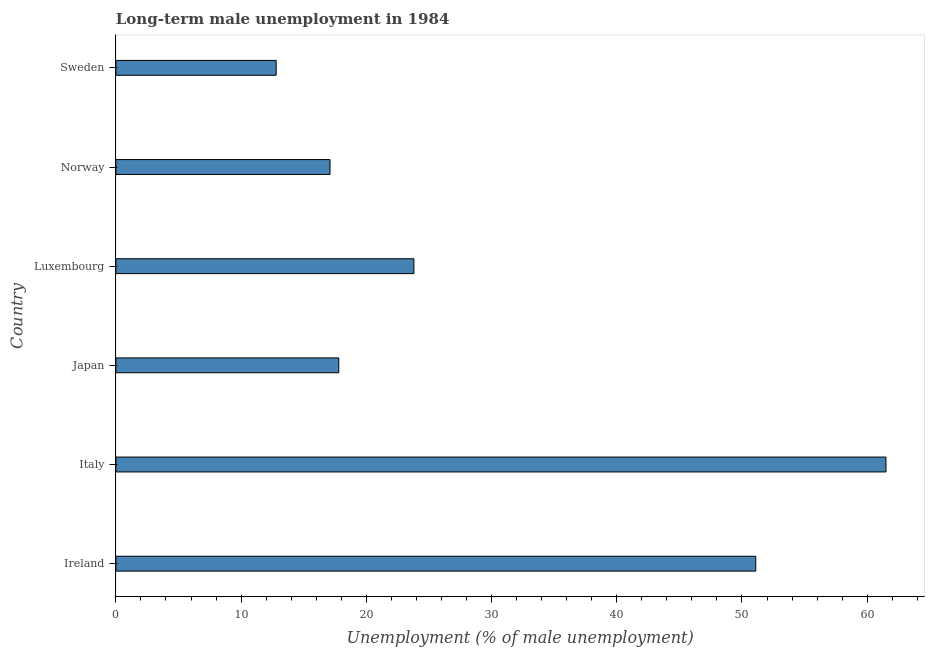Does the graph contain grids?
Offer a terse response. No. What is the title of the graph?
Provide a short and direct response. Long-term male unemployment in 1984. What is the label or title of the X-axis?
Your response must be concise. Unemployment (% of male unemployment). What is the label or title of the Y-axis?
Make the answer very short. Country. What is the long-term male unemployment in Japan?
Your response must be concise. 17.8. Across all countries, what is the maximum long-term male unemployment?
Keep it short and to the point. 61.5. Across all countries, what is the minimum long-term male unemployment?
Keep it short and to the point. 12.8. In which country was the long-term male unemployment maximum?
Keep it short and to the point. Italy. What is the sum of the long-term male unemployment?
Give a very brief answer. 184.1. What is the average long-term male unemployment per country?
Offer a terse response. 30.68. What is the median long-term male unemployment?
Offer a very short reply. 20.8. In how many countries, is the long-term male unemployment greater than 48 %?
Give a very brief answer. 2. What is the ratio of the long-term male unemployment in Ireland to that in Norway?
Make the answer very short. 2.99. Is the long-term male unemployment in Ireland less than that in Luxembourg?
Give a very brief answer. No. Is the difference between the long-term male unemployment in Ireland and Italy greater than the difference between any two countries?
Make the answer very short. No. What is the difference between the highest and the lowest long-term male unemployment?
Provide a succinct answer. 48.7. What is the difference between two consecutive major ticks on the X-axis?
Your answer should be compact. 10. What is the Unemployment (% of male unemployment) of Ireland?
Your response must be concise. 51.1. What is the Unemployment (% of male unemployment) of Italy?
Give a very brief answer. 61.5. What is the Unemployment (% of male unemployment) of Japan?
Give a very brief answer. 17.8. What is the Unemployment (% of male unemployment) in Luxembourg?
Your response must be concise. 23.8. What is the Unemployment (% of male unemployment) of Norway?
Make the answer very short. 17.1. What is the Unemployment (% of male unemployment) in Sweden?
Your answer should be very brief. 12.8. What is the difference between the Unemployment (% of male unemployment) in Ireland and Italy?
Your answer should be compact. -10.4. What is the difference between the Unemployment (% of male unemployment) in Ireland and Japan?
Your answer should be compact. 33.3. What is the difference between the Unemployment (% of male unemployment) in Ireland and Luxembourg?
Offer a very short reply. 27.3. What is the difference between the Unemployment (% of male unemployment) in Ireland and Norway?
Provide a short and direct response. 34. What is the difference between the Unemployment (% of male unemployment) in Ireland and Sweden?
Offer a very short reply. 38.3. What is the difference between the Unemployment (% of male unemployment) in Italy and Japan?
Make the answer very short. 43.7. What is the difference between the Unemployment (% of male unemployment) in Italy and Luxembourg?
Your response must be concise. 37.7. What is the difference between the Unemployment (% of male unemployment) in Italy and Norway?
Give a very brief answer. 44.4. What is the difference between the Unemployment (% of male unemployment) in Italy and Sweden?
Keep it short and to the point. 48.7. What is the difference between the Unemployment (% of male unemployment) in Japan and Luxembourg?
Your answer should be compact. -6. What is the difference between the Unemployment (% of male unemployment) in Luxembourg and Norway?
Make the answer very short. 6.7. What is the difference between the Unemployment (% of male unemployment) in Luxembourg and Sweden?
Provide a succinct answer. 11. What is the ratio of the Unemployment (% of male unemployment) in Ireland to that in Italy?
Make the answer very short. 0.83. What is the ratio of the Unemployment (% of male unemployment) in Ireland to that in Japan?
Ensure brevity in your answer.  2.87. What is the ratio of the Unemployment (% of male unemployment) in Ireland to that in Luxembourg?
Offer a terse response. 2.15. What is the ratio of the Unemployment (% of male unemployment) in Ireland to that in Norway?
Offer a very short reply. 2.99. What is the ratio of the Unemployment (% of male unemployment) in Ireland to that in Sweden?
Ensure brevity in your answer.  3.99. What is the ratio of the Unemployment (% of male unemployment) in Italy to that in Japan?
Keep it short and to the point. 3.46. What is the ratio of the Unemployment (% of male unemployment) in Italy to that in Luxembourg?
Provide a succinct answer. 2.58. What is the ratio of the Unemployment (% of male unemployment) in Italy to that in Norway?
Provide a succinct answer. 3.6. What is the ratio of the Unemployment (% of male unemployment) in Italy to that in Sweden?
Keep it short and to the point. 4.8. What is the ratio of the Unemployment (% of male unemployment) in Japan to that in Luxembourg?
Provide a succinct answer. 0.75. What is the ratio of the Unemployment (% of male unemployment) in Japan to that in Norway?
Provide a succinct answer. 1.04. What is the ratio of the Unemployment (% of male unemployment) in Japan to that in Sweden?
Keep it short and to the point. 1.39. What is the ratio of the Unemployment (% of male unemployment) in Luxembourg to that in Norway?
Give a very brief answer. 1.39. What is the ratio of the Unemployment (% of male unemployment) in Luxembourg to that in Sweden?
Ensure brevity in your answer.  1.86. What is the ratio of the Unemployment (% of male unemployment) in Norway to that in Sweden?
Give a very brief answer. 1.34. 